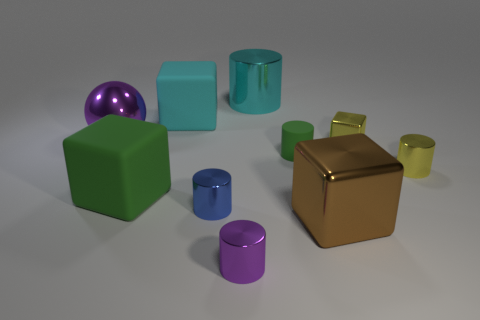There is a purple thing behind the brown metal block; what shape is it?
Offer a terse response. Sphere. What is the size of the yellow object that is the same material as the yellow cylinder?
Give a very brief answer. Small. What number of tiny yellow metal things have the same shape as the brown metallic thing?
Give a very brief answer. 1. There is a big cube that is on the right side of the large cyan rubber thing; is it the same color as the large cylinder?
Ensure brevity in your answer.  No. What number of large cyan metal cylinders are in front of the large cyan object that is to the left of the metallic cylinder behind the tiny rubber cylinder?
Your answer should be compact. 0. What number of large things are both left of the purple cylinder and in front of the small green matte cylinder?
Keep it short and to the point. 1. There is a small metallic thing that is the same color as the big sphere; what shape is it?
Make the answer very short. Cylinder. Is there any other thing that has the same material as the small blue cylinder?
Provide a succinct answer. Yes. Does the large green cube have the same material as the blue object?
Your answer should be very brief. No. There is a cyan object that is on the right side of the tiny cylinder on the left side of the purple metallic thing in front of the tiny blue metallic object; what is its shape?
Keep it short and to the point. Cylinder. 